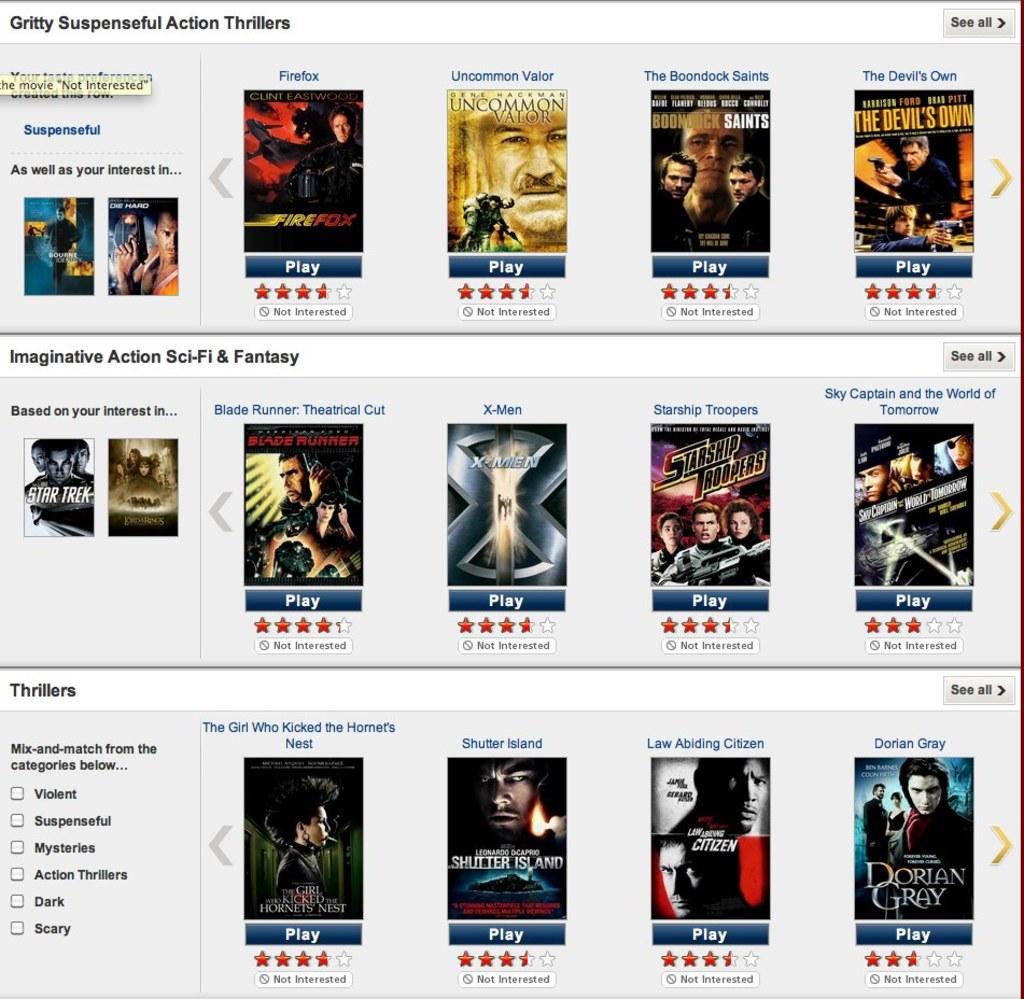What movie is on the bottom rihgt?
Give a very brief answer. Dorian gray. What is the title of the top left movie?
Ensure brevity in your answer.  Firefox. 